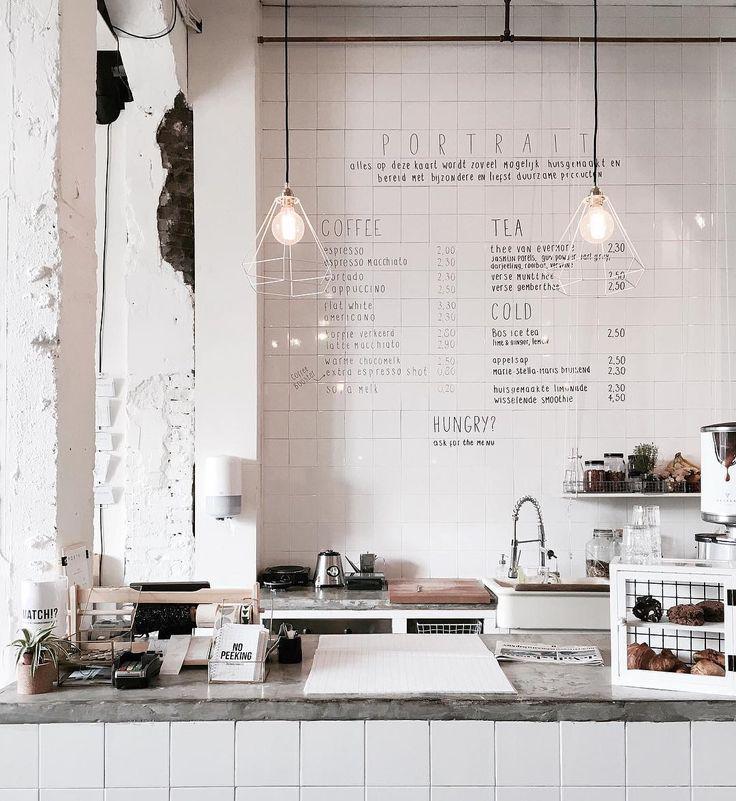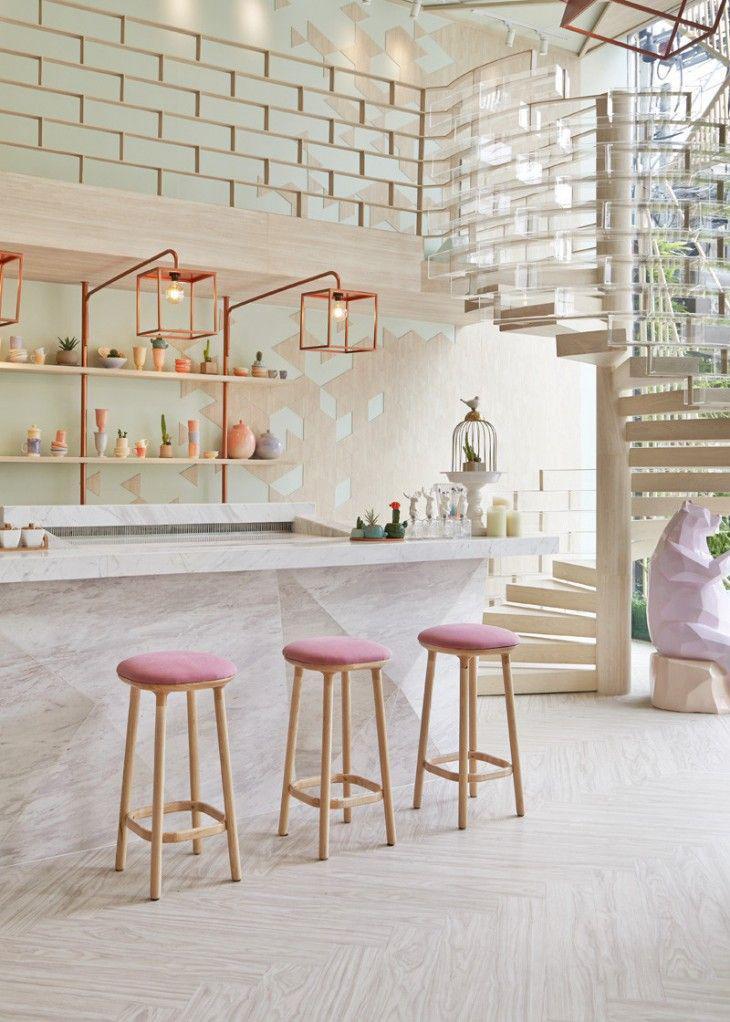The first image is the image on the left, the second image is the image on the right. Considering the images on both sides, is "Some of the white chairs are made of metal." valid? Answer yes or no. No. The first image is the image on the left, the second image is the image on the right. Evaluate the accuracy of this statement regarding the images: "Each image shows a cafe with seating on white chairs near an interior brick wall, but potted plants are in only one image.". Is it true? Answer yes or no. No. 